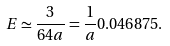<formula> <loc_0><loc_0><loc_500><loc_500>E \simeq \frac { 3 } { 6 4 a } = \frac { 1 } { a } 0 . 0 4 6 8 7 5 .</formula> 